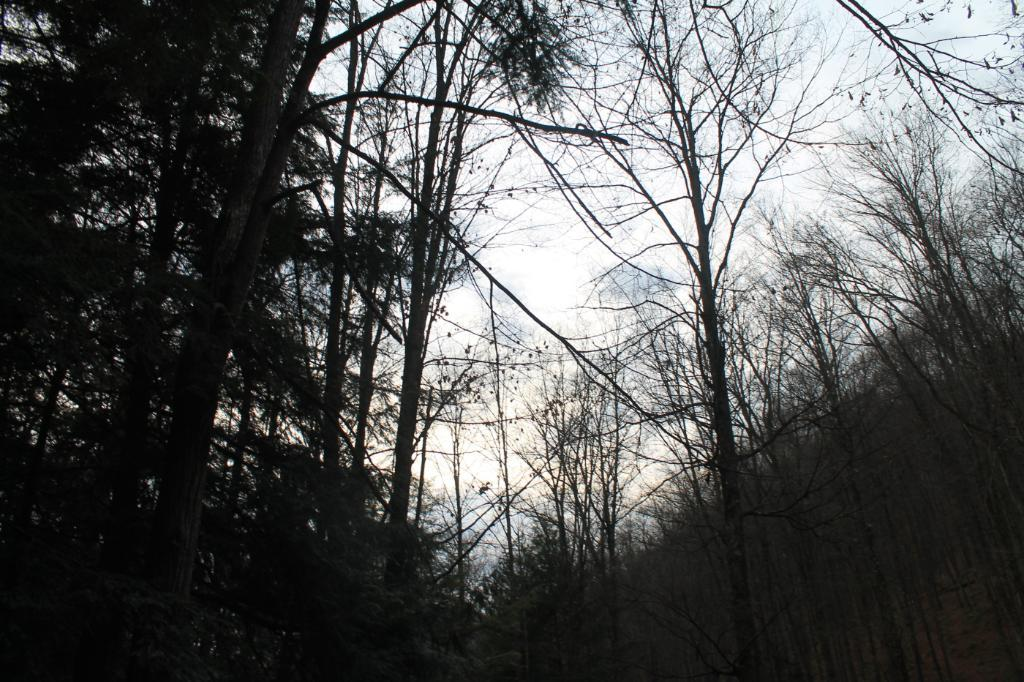What type of vegetation can be seen in the image? There are trees in the image. What can be seen in the sky in the background of the image? Clouds are visible in the background of the image. What else is visible in the background of the image? The sky is visible in the background of the image. What type of love can be seen in the image? There is no love present in the image; it features trees and a sky with clouds. What direction are the trees looking in the image? Trees do not have the ability to look in a specific direction, so this question cannot be answered definitively. 